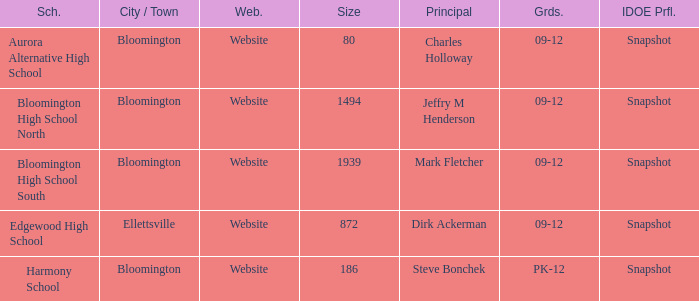How many websites are there for the school with 1939 students? 1.0. 